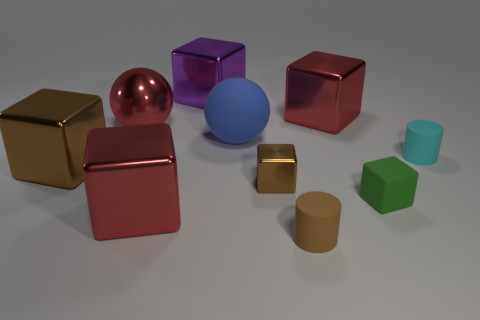There is a rubber cylinder that is the same color as the small metal cube; what size is it?
Your answer should be compact. Small. There is a tiny matte thing that is the same color as the small shiny cube; what is its shape?
Give a very brief answer. Cylinder. How big is the sphere to the right of the large purple shiny object that is left of the red metallic cube behind the cyan cylinder?
Ensure brevity in your answer.  Large. What material is the purple thing?
Offer a terse response. Metal. Are the big red ball and the cylinder in front of the cyan matte thing made of the same material?
Ensure brevity in your answer.  No. Is there anything else that has the same color as the big matte thing?
Give a very brief answer. No. Is there a cylinder that is on the left side of the big cube that is in front of the brown metallic cube that is right of the matte sphere?
Your answer should be compact. No. The large rubber thing has what color?
Ensure brevity in your answer.  Blue. There is a large brown metallic block; are there any small green cubes behind it?
Make the answer very short. No. Is the shape of the large purple thing the same as the shiny thing that is on the right side of the brown cylinder?
Keep it short and to the point. Yes. 